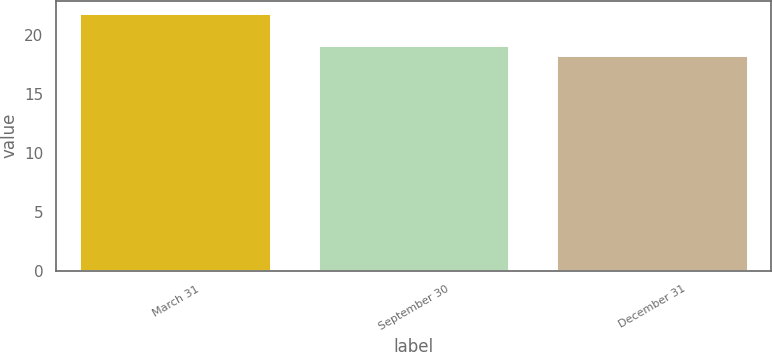Convert chart. <chart><loc_0><loc_0><loc_500><loc_500><bar_chart><fcel>March 31<fcel>September 30<fcel>December 31<nl><fcel>21.87<fcel>19.13<fcel>18.24<nl></chart> 